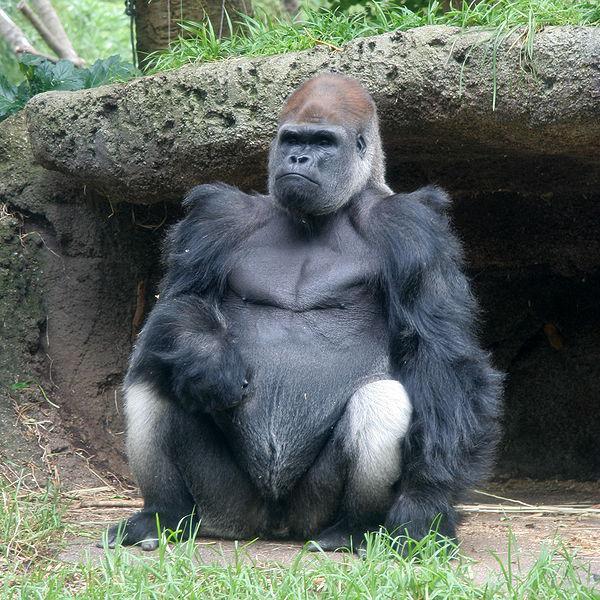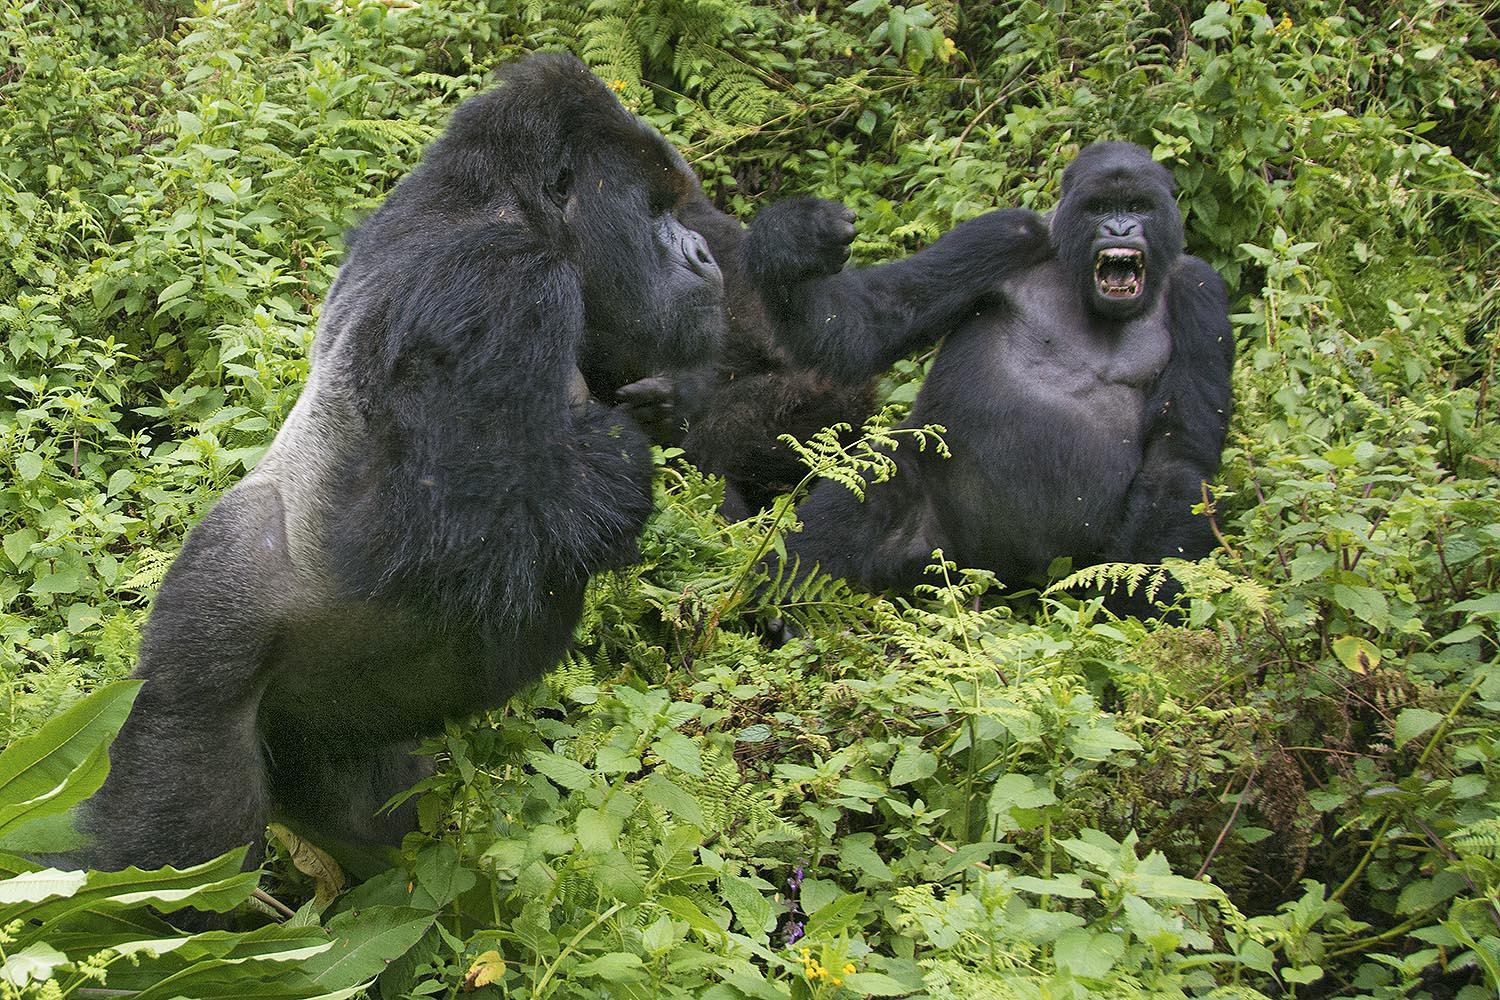The first image is the image on the left, the second image is the image on the right. Analyze the images presented: Is the assertion "All of the images only contain one gorilla." valid? Answer yes or no. No. The first image is the image on the left, the second image is the image on the right. For the images displayed, is the sentence "There are two gorillas total." factually correct? Answer yes or no. No. 